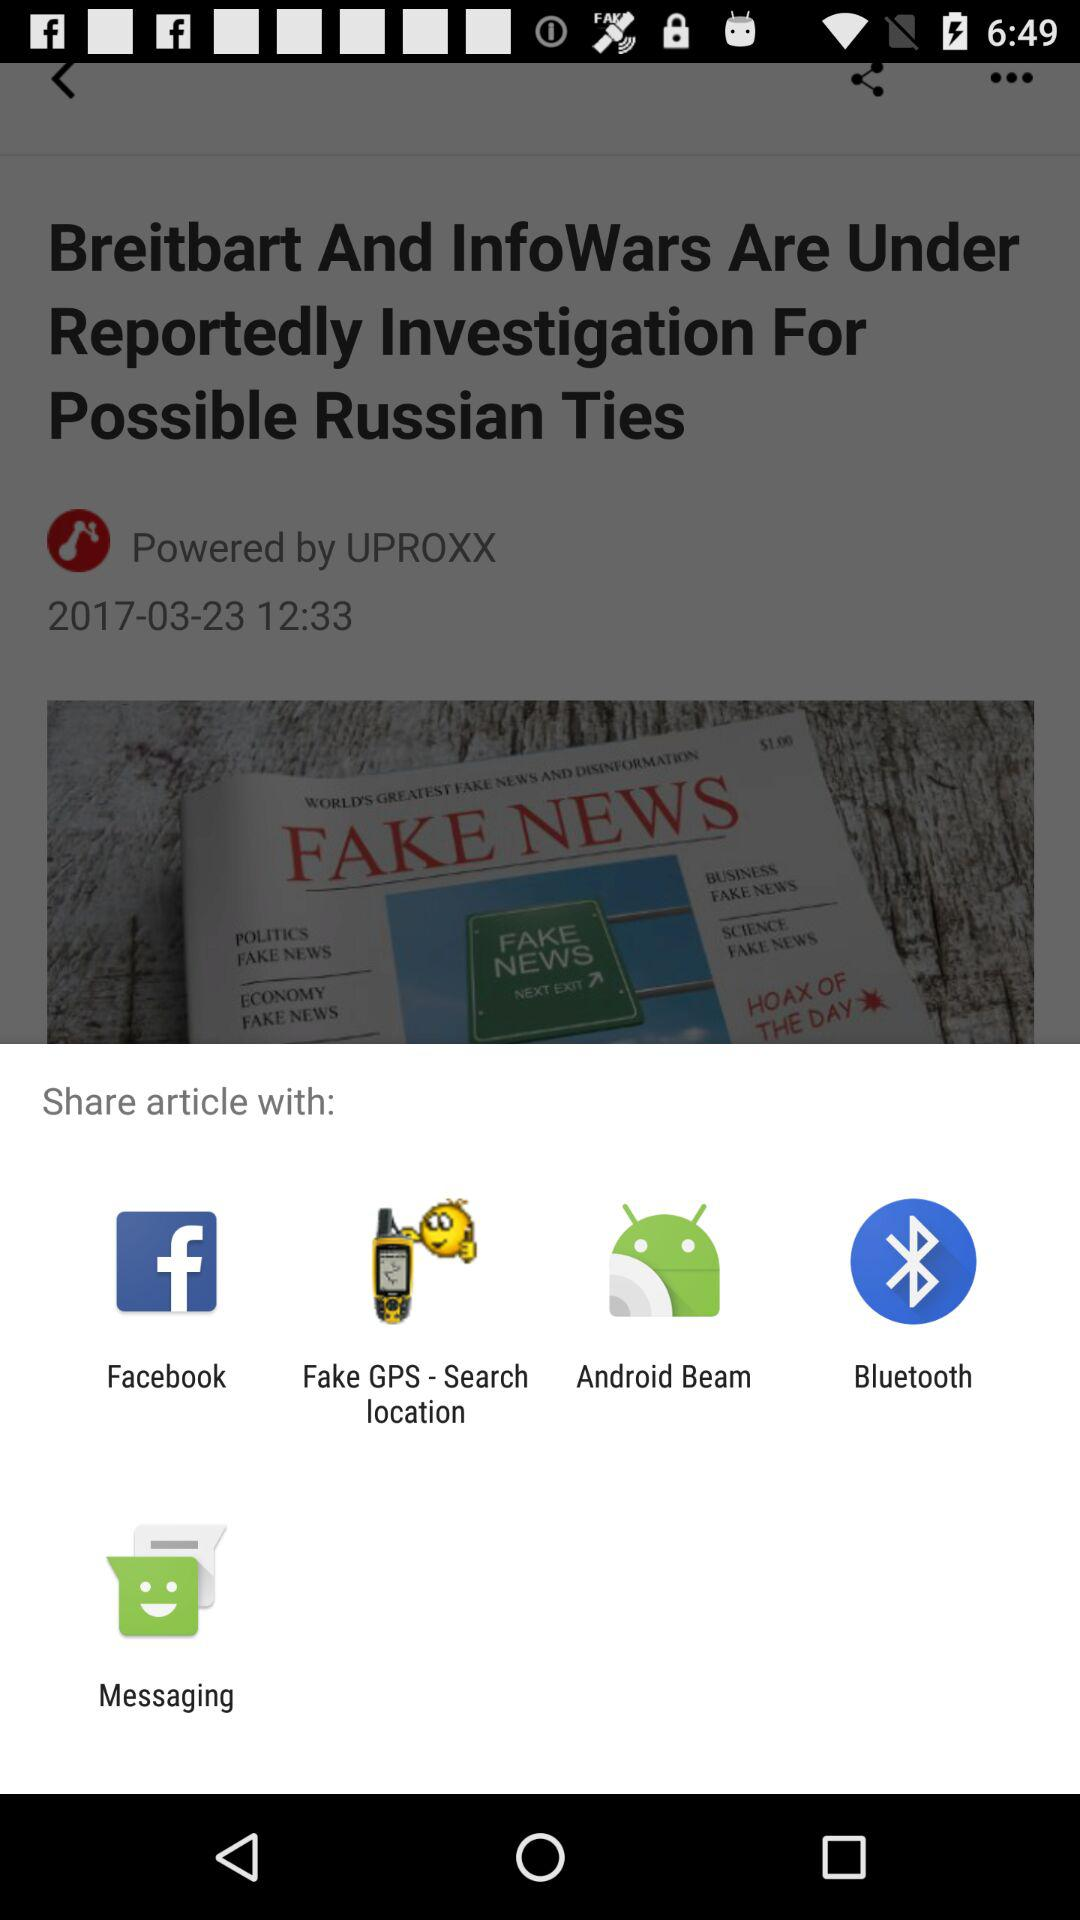What are the different applications through which we can share the article? The applications are "Facebook", "Fake GPS - Search location", "Android Beam", "Bluetooth" and "Messaging". 